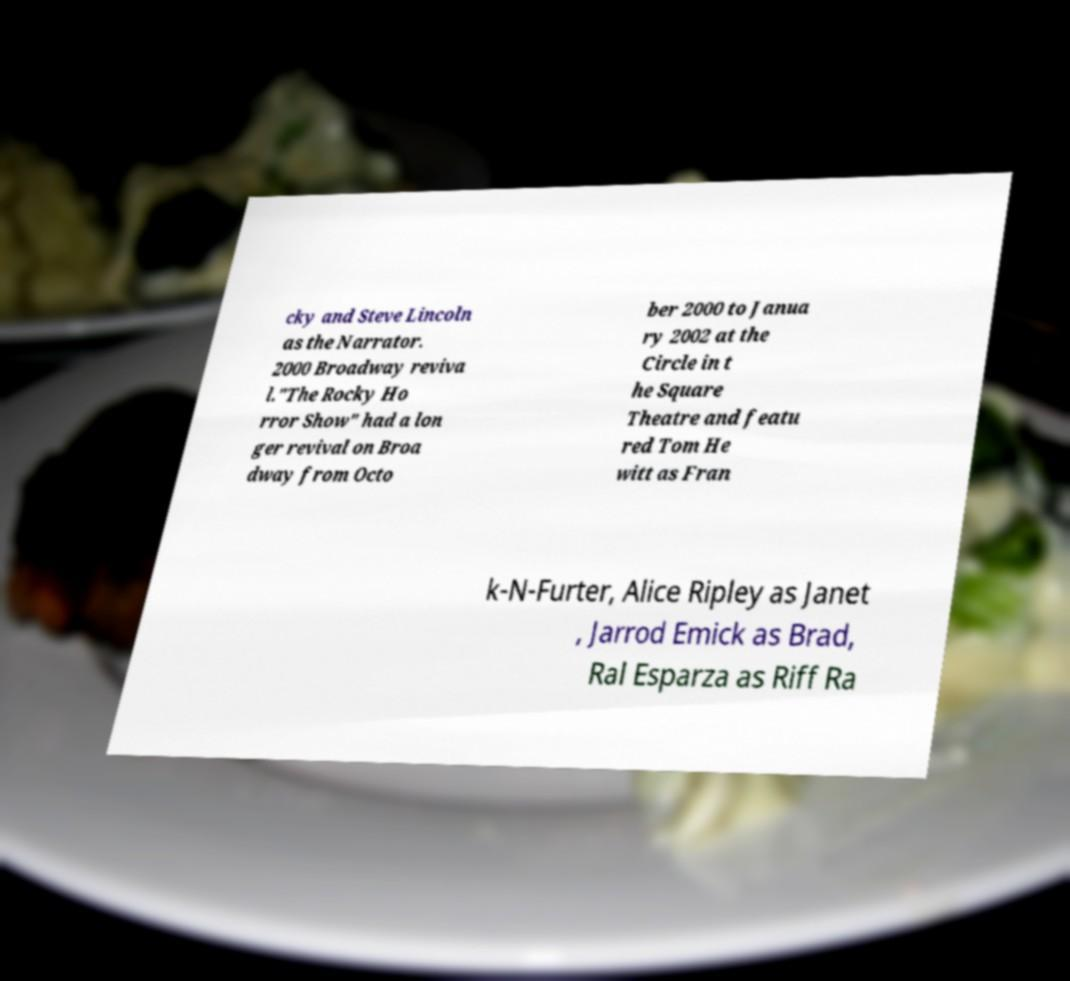I need the written content from this picture converted into text. Can you do that? cky and Steve Lincoln as the Narrator. 2000 Broadway reviva l."The Rocky Ho rror Show" had a lon ger revival on Broa dway from Octo ber 2000 to Janua ry 2002 at the Circle in t he Square Theatre and featu red Tom He witt as Fran k-N-Furter, Alice Ripley as Janet , Jarrod Emick as Brad, Ral Esparza as Riff Ra 